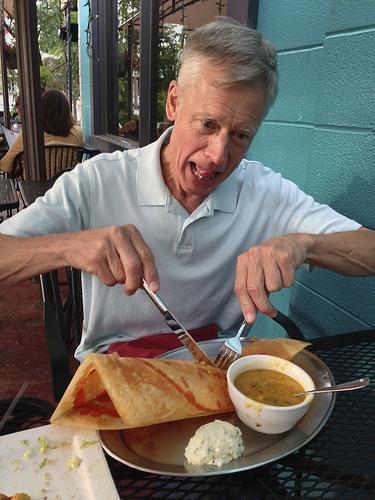How many spoons are in this picture?
Give a very brief answer. 1. How many utensil are been actively used in the image?
Give a very brief answer. 2. 